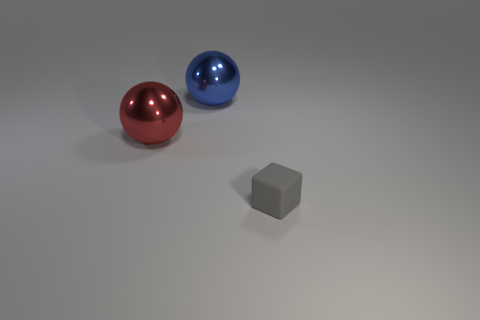Can you describe the lighting of the scene and how it affects the appearance of the objects? The scene is illuminated by a soft, diffuse overhead light that casts subtle shadows underneath the objects, which suggests a neutral ambiance. It enhances the metallic sheen of the spheres, emphasizing their color and reflective properties. 